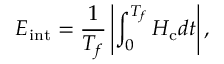Convert formula to latex. <formula><loc_0><loc_0><loc_500><loc_500>E _ { i n t } = \frac { 1 } { T _ { f } } \left | \int _ { 0 } ^ { T _ { f } } H _ { c } d t \right | ,</formula> 